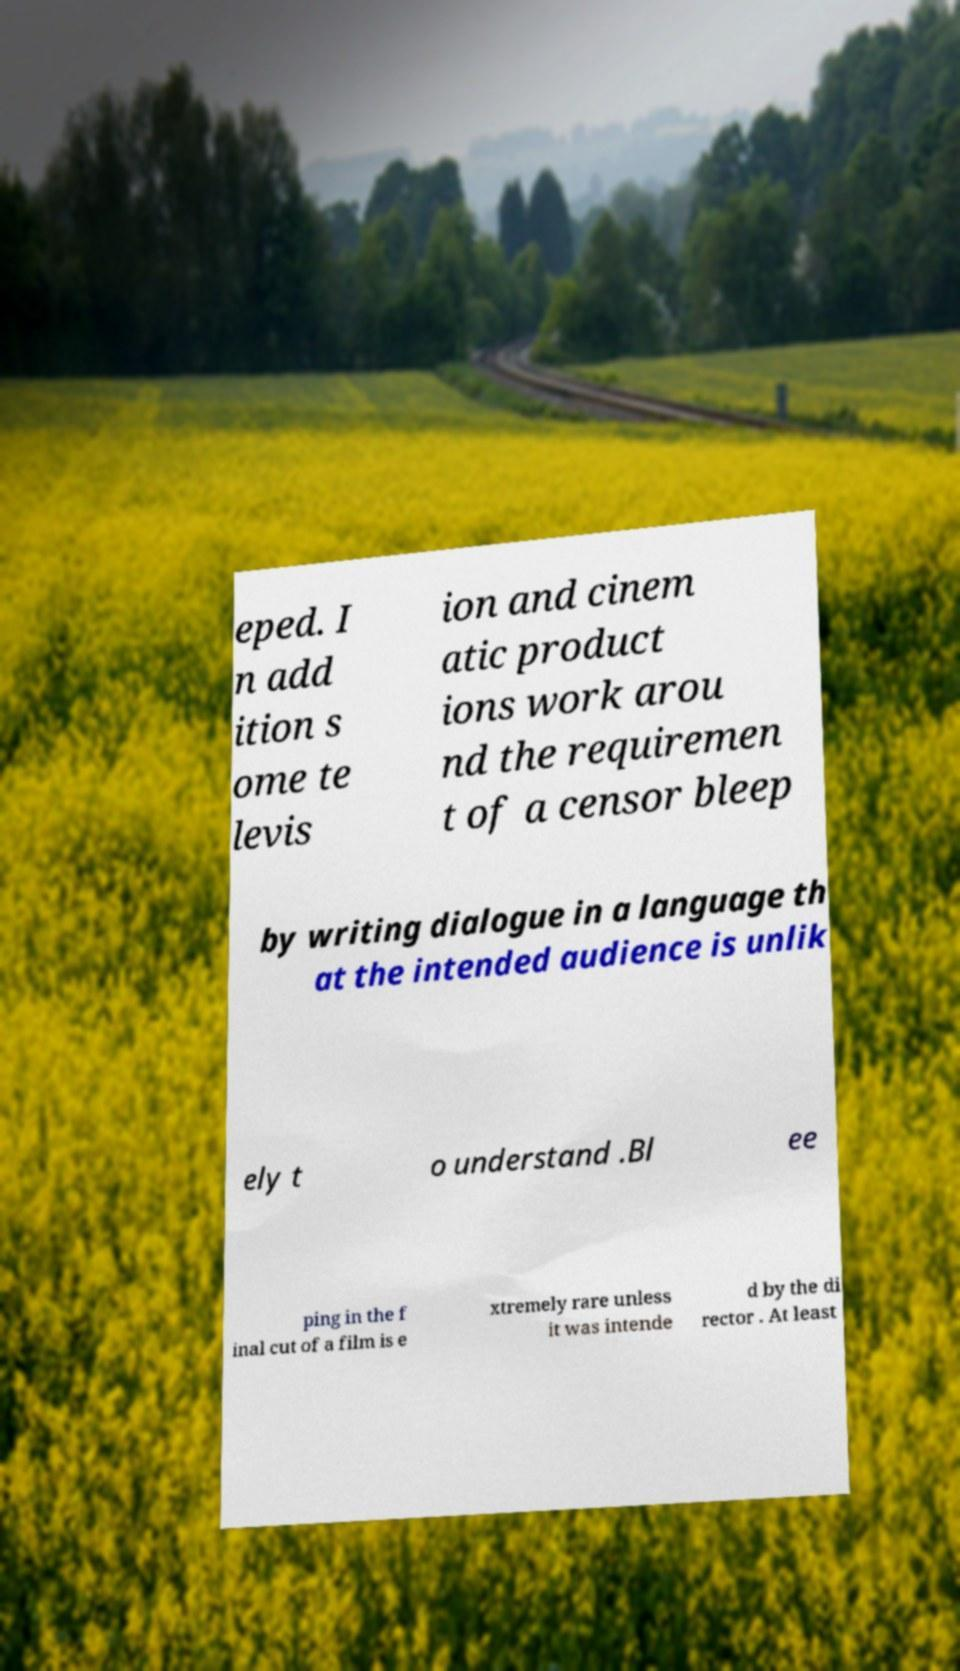Can you read and provide the text displayed in the image?This photo seems to have some interesting text. Can you extract and type it out for me? eped. I n add ition s ome te levis ion and cinem atic product ions work arou nd the requiremen t of a censor bleep by writing dialogue in a language th at the intended audience is unlik ely t o understand .Bl ee ping in the f inal cut of a film is e xtremely rare unless it was intende d by the di rector . At least 